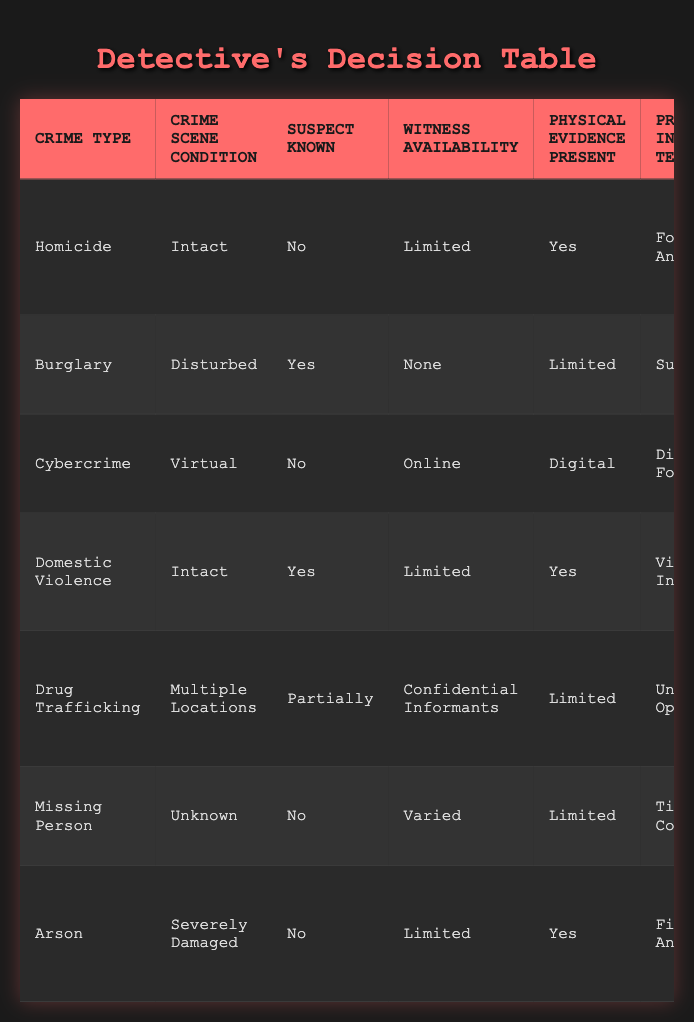What is the primary investigative technique for Homicide cases? The table shows that for Homicide cases, the primary investigative technique listed is Forensic Analysis.
Answer: Forensic Analysis Are there any crime types where the primary investigative technique is Digital Forensics? Yes, the table indicates that Cybercrime is the only crime type where the primary investigative technique is Digital Forensics.
Answer: Yes What is the primary investigative technique for Burglary incidents with a known suspect? The table states that for Burglary with a known suspect, the primary investigative technique is Surveillance.
Answer: Surveillance How many investigative techniques are recommended for Drug Trafficking? The table indicates that 2 techniques are recommended: Undercover Operations as the primary and Financial Investigation as the secondary technique.
Answer: 2 Is there any crime type listed that has Physical Evidence Present as 'No'? By reviewing the table, it can be observed that all crime types listed have Physical Evidence Present marked as either 'Yes' or 'Limited', indicating that none have 'No'.
Answer: No Which investigative technique appears most frequently as the primary method across all crime types? By examining the table, Forensic Analysis is the primary investigative technique for Homicide, while Digital Forensics is for Cybercrime, and others vary. Since there’s no repeat, no technique appears most frequently.
Answer: None What is the relationship between Witness Availability and the Primary Investigative Technique for Domestic Violence cases? The table shows that for Domestic Violence, with limited witness availability, the primary investigative technique is Victim Interview, highlighting a direct connection between the technique and witness availability as crucial for gathering information.
Answer: Victim Interview For crimes involving Physical Evidence, what are the Secondary Investigative Techniques? Reviewing the table for crimes with Physical Evidence, the secondary techniques are: Canvassing for Homicide, Evidence Collection for Domestic Violence, Chemical Residue Testing for Arson, and none for Burglary and Drug Trafficking.
Answer: Multiple responses required What special considerations are advised for cybercrime investigations? According to the table, the special considerations for cybercrime indicate to delegate tasks to avoid overwhelming workload, focusing on managing the mental strain during investigation.
Answer: Delegate tasks How does the investigative technique change between a known suspect and an unknown suspect in Domestic Violence cases? The table shows that if a suspect is known, the primary technique is Victim Interview, whereas if the suspect is unknown, different techniques might be necessary. This indicates a shift based on the suspect's information.
Answer: Victim Interview vs. different techniques 